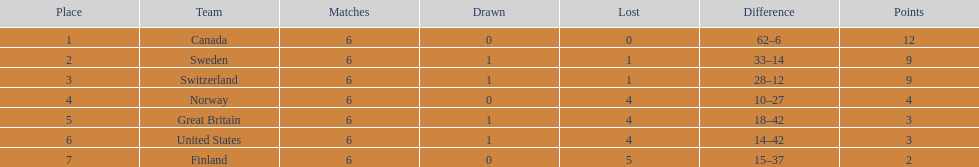How many teams won 6 matches? 1. 